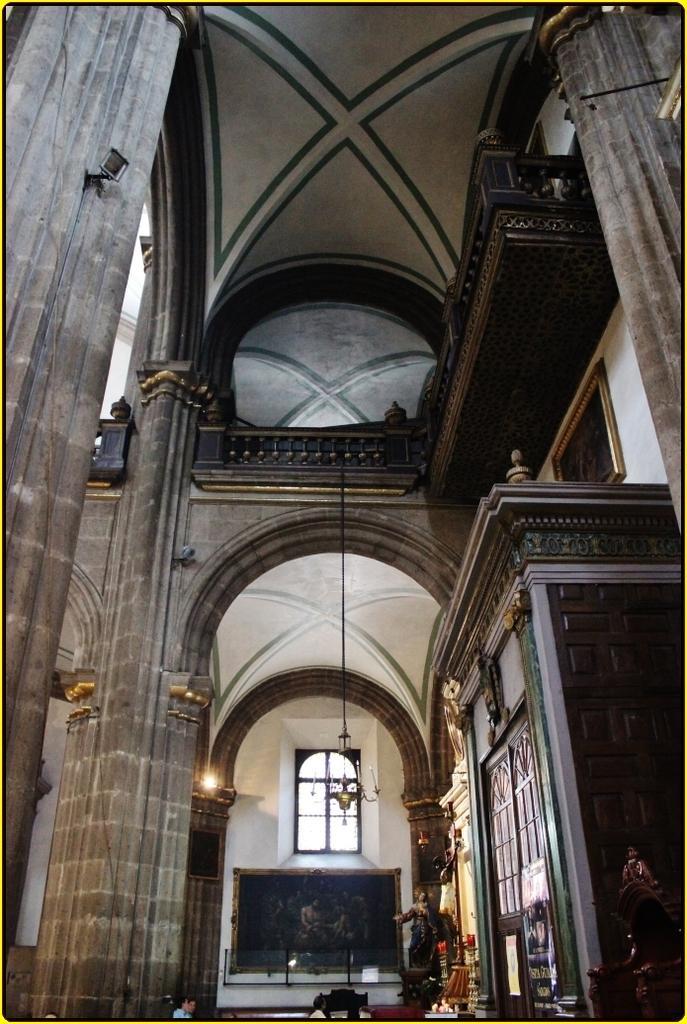How would you summarize this image in a sentence or two? It seems to be the image is inside the room. In the image on right side we can see a door which is closed and a sculptures in middle there is a photo frame on wall on top there is a roof and pillars. 